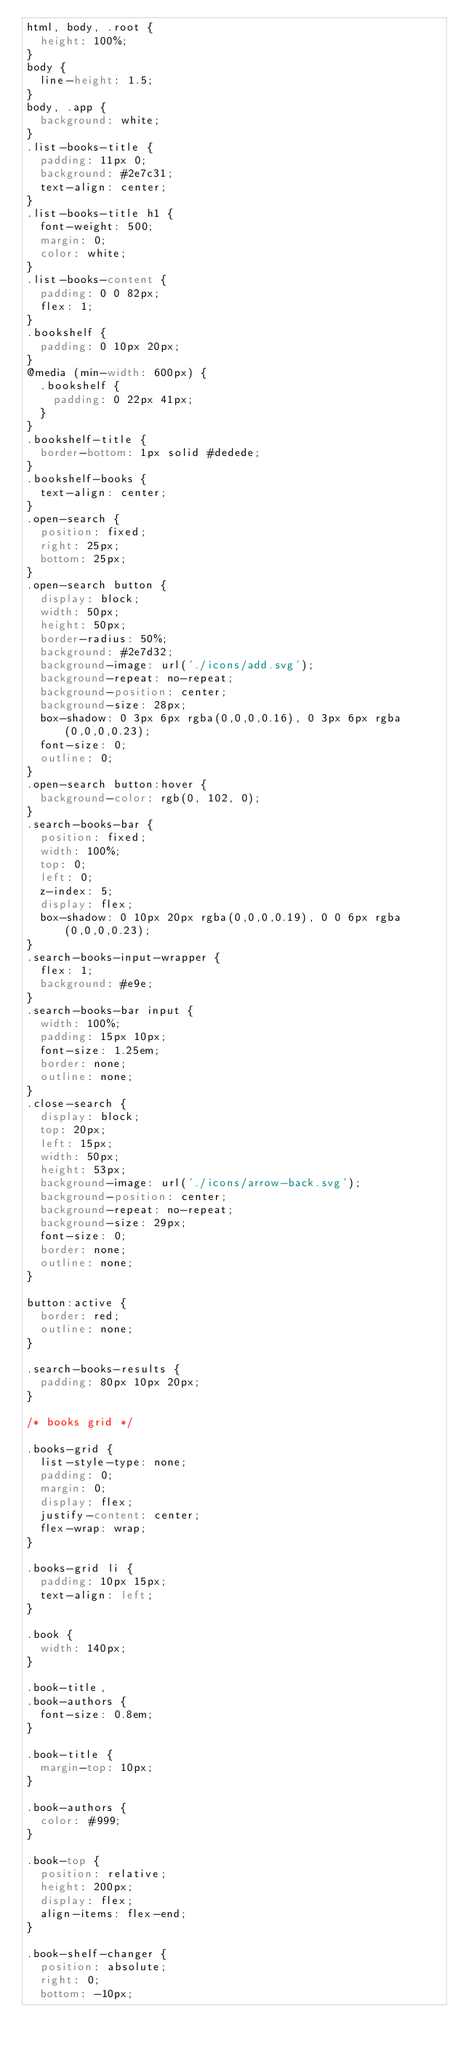Convert code to text. <code><loc_0><loc_0><loc_500><loc_500><_CSS_>html, body, .root {
  height: 100%;
}
body {
  line-height: 1.5;
}
body, .app {
  background: white;
}
.list-books-title {
  padding: 11px 0;
  background: #2e7c31;
  text-align: center;
}
.list-books-title h1 {
  font-weight: 500;
  margin: 0;
  color: white;
}
.list-books-content {
  padding: 0 0 82px;
  flex: 1;
}
.bookshelf {
  padding: 0 10px 20px;
}
@media (min-width: 600px) {
  .bookshelf {
    padding: 0 22px 41px;
  }
}
.bookshelf-title {
  border-bottom: 1px solid #dedede;
}
.bookshelf-books {
  text-align: center;
}
.open-search {
  position: fixed;
  right: 25px;
  bottom: 25px;
}
.open-search button {
  display: block;
  width: 50px;
  height: 50px;
  border-radius: 50%;
  background: #2e7d32;
  background-image: url('./icons/add.svg');
  background-repeat: no-repeat;
  background-position: center;
  background-size: 28px;
  box-shadow: 0 3px 6px rgba(0,0,0,0.16), 0 3px 6px rgba(0,0,0,0.23);
  font-size: 0;
  outline: 0;
}
.open-search button:hover {
  background-color: rgb(0, 102, 0);
}
.search-books-bar {
  position: fixed;
  width: 100%;
  top: 0;
  left: 0;
  z-index: 5;
  display: flex;
  box-shadow: 0 10px 20px rgba(0,0,0,0.19), 0 0 6px rgba(0,0,0,0.23);
}
.search-books-input-wrapper {
  flex: 1;
  background: #e9e;
}
.search-books-bar input {
  width: 100%;
  padding: 15px 10px;
  font-size: 1.25em;
  border: none;
  outline: none;
}
.close-search {
  display: block;
  top: 20px;
  left: 15px;
  width: 50px;
  height: 53px;
  background-image: url('./icons/arrow-back.svg');
  background-position: center;
  background-repeat: no-repeat;
  background-size: 29px;
  font-size: 0;
  border: none;
  outline: none;
}

button:active {
  border: red;
  outline: none;
}

.search-books-results {
  padding: 80px 10px 20px;
}

/* books grid */

.books-grid {
  list-style-type: none;
  padding: 0;
  margin: 0;
  display: flex;
  justify-content: center;
  flex-wrap: wrap;
}

.books-grid li {
  padding: 10px 15px;
  text-align: left;
}

.book {
  width: 140px;
}

.book-title,
.book-authors {
  font-size: 0.8em;
}

.book-title {
  margin-top: 10px;
}

.book-authors {
  color: #999;
}

.book-top {
  position: relative;
  height: 200px;
  display: flex;
  align-items: flex-end;
}

.book-shelf-changer {
  position: absolute;
  right: 0;
  bottom: -10px;</code> 